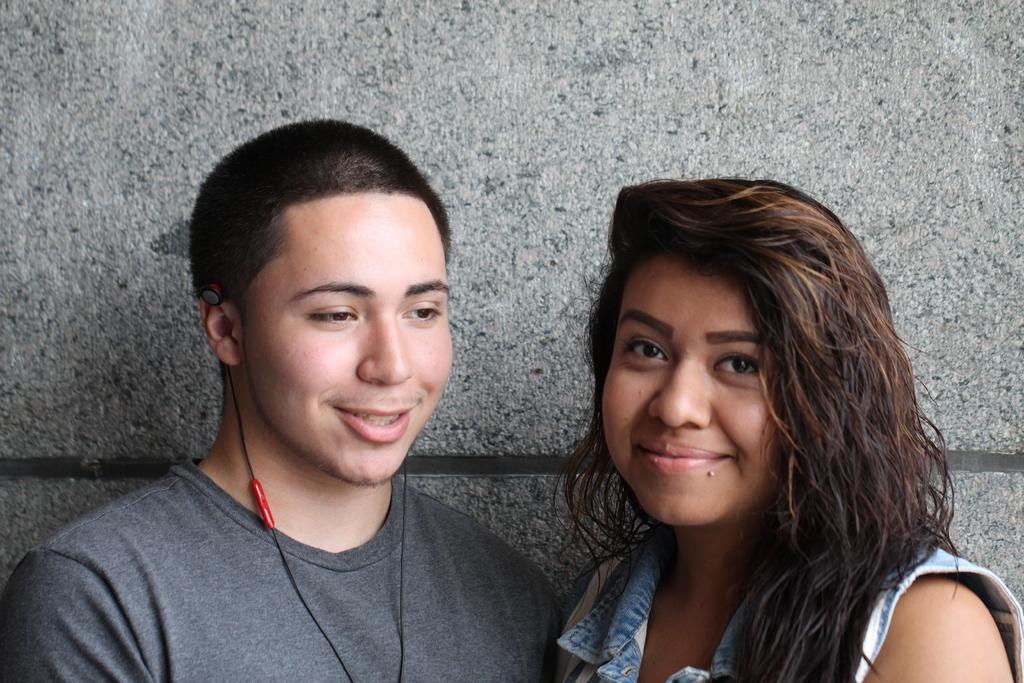How would you summarize this image in a sentence or two? In this image we can see a man and a woman. They are smiling. In the background there is a wall. 